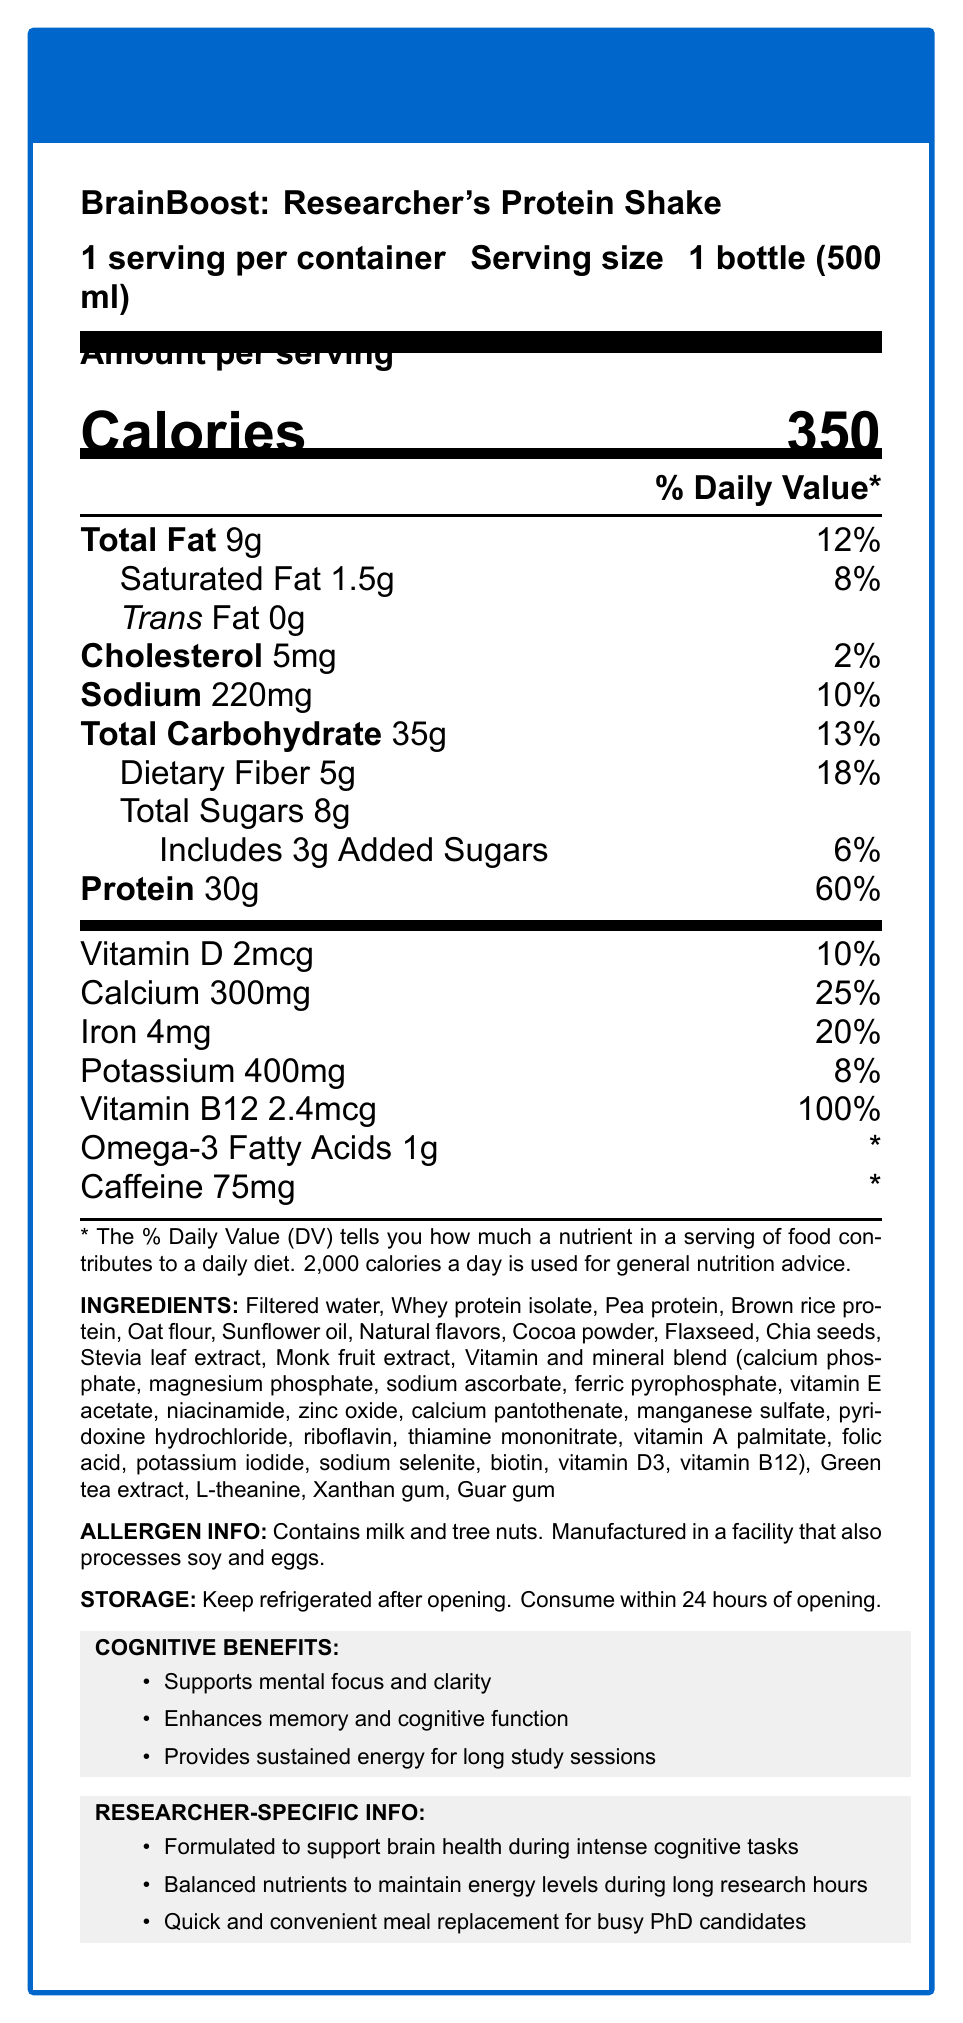short-answer: How many grams of total fat are in one serving? The document states "Total Fat 9g" under the nutrition facts section.
Answer: 9 grams short-answer: What is the serving size of the BrainBoost shake? The document specifies, "Serving size: 1 bottle (500 ml)" under the product name.
Answer: 1 bottle (500 ml) short-answer: How much protein is in one serving of this shake? The document indicates "Protein 30g" under the nutrition facts section.
Answer: 30 grams short-answer: What percentage of the daily value of calcium does one serving provide? The document lists "Calcium 300mg" and indicates it provides 25% of the daily value.
Answer: 25% short-answer: What is the amount of potassium in one bottle of the shake? The document specifies "Potassium 400mg" under the nutrition facts.
Answer: 400 mg multiple-choice: Which cognitive benefit is NOT listed for this shake? A. Supports mental focus B. Enhances creativity C. Provides sustained energy The document lists "Supports mental focus," "Enhances memory and cognitive function," and "Provides sustained energy," but does not mention enhancing creativity.
Answer: B multiple-choice: How much daily value of fiber does one serving have?  A. 10% B. 18% C. 25% D. 30% The document states "Dietary Fiber 5g" amounting to 18% of the daily value.
Answer: B Yes/No: Does the shake contain any trans fat? The document indicates "Trans Fat 0g".
Answer: No summary: Can you summarize the nutritional benefits and target audience for this shake? The document outlines that the shake is geared towards researchers with demanding cognitive tasks, providing essential nutrients and cognitive support for long study sessions.
Answer: The BrainBoost: Researcher's Protein Shake is designed for busy researchers and PhD candidates. It provides 30g of protein, supports mental focus, enhances cognitive function, and offers sustained energy. It contains a blend of whey, pea, and rice proteins, and is rich in vitamins and minerals like Vitamin B12, calcium, and iron. unanswerable: What is the price of the BrainBoost shake? The document does not provide any details related to the price of the BrainBoost shake.
Answer: Not enough information 